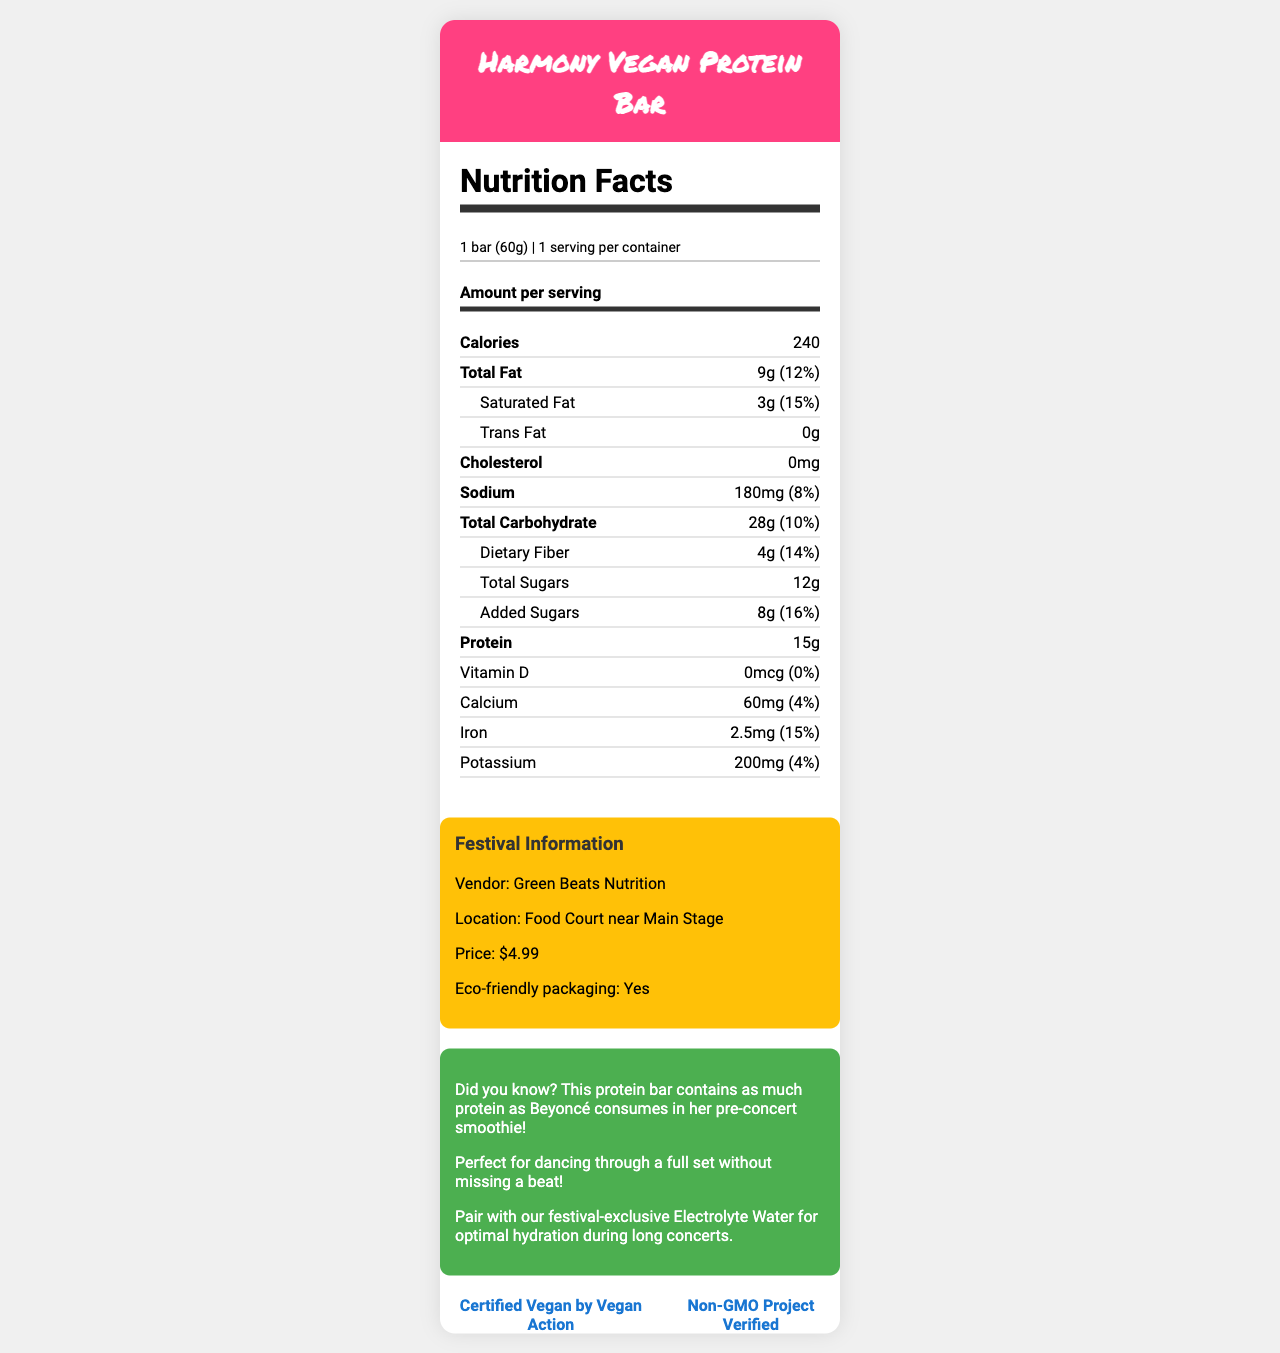how many servings are in one container of the Harmony Vegan Protein Bar? The serving info states "1 bar (60g)" and "1 serving per container."
Answer: 1 serving what is the total fat content in the Harmony Vegan Protein Bar? The document lists "Total Fat" as 9g with a daily value percentage of 12%.
Answer: 9g which ingredients are included in the Harmony Vegan Protein Bar? The "Ingredients" section lists all these components.
Answer: Pea protein isolate, Brown rice syrup, Cashew butter, Dried cranberries, Pumpkin seeds, Chia seeds, Natural flavors, Sea salt what is the daily value percentage of dietary fiber in the Harmony Vegan Protein Bar? The document lists dietary fiber content as "4g," which corresponds to 14% of the daily value.
Answer: 14% what is the price of the Harmony Vegan Protein Bar at the festival food stand? The "Festival Information" section states the price as $4.99.
Answer: $4.99 what can you pair with the Harmony Vegan Protein Bar for optimal hydration? A. Electrolyte Water B. Vitamin Water C. Lemonade D. Juice The "music-related facts" section suggests pairing with "festival-exclusive Electrolyte Water for optimal hydration during long concerts."
Answer: A. Electrolyte Water which certification does the Harmony Vegan Protein Bar have? i. Certified Non-GMO ii. USDA Organic iii. Certified Vegan iv. Kosher The "certifications" section includes "Certified Vegan by Vegan Action" and "Non-GMO Project Verified."
Answer: iii. Certified Vegan does the Harmony Vegan Protein Bar contain any cholesterol? The document lists "Cholesterol: 0mg."
Answer: No what is the main idea of the document? The document combines nutritional facts, ingredients, certifications, and special festival-related information to provide a comprehensive overview of the Harmony Vegan Protein Bar, emphasizing its vegan and sustainable qualities and its availability at a music festival.
Answer: The document details the nutritional information, ingredients, and festival-specific details of the Harmony Vegan Protein Bar, highlighting its suitability for concert-goers with a focus on vegan and eco-friendly aspects. who is the vendor selling the Harmony Vegan Protein Bar at the festival? The "Festival Information" section lists "Vendor: Green Beats Nutrition."
Answer: Green Beats Nutrition how often does Beyoncé consume as much protein as is in the Harmony Vegan Protein Bar? The document contains a fun fact linking the bar's protein to Beyoncé’s pre-concert smoothie, but it doesn't provide information about the frequency of her consumption.
Answer: Cannot be determined is the wrapper of the Harmony Vegan Protein Bar compostable? The document states "Wrapper is compostable at designated festival recycling stations."
Answer: Yes how much protein does the Harmony Vegan Protein Bar contain? The document lists "Protein: 15g."
Answer: 15g 